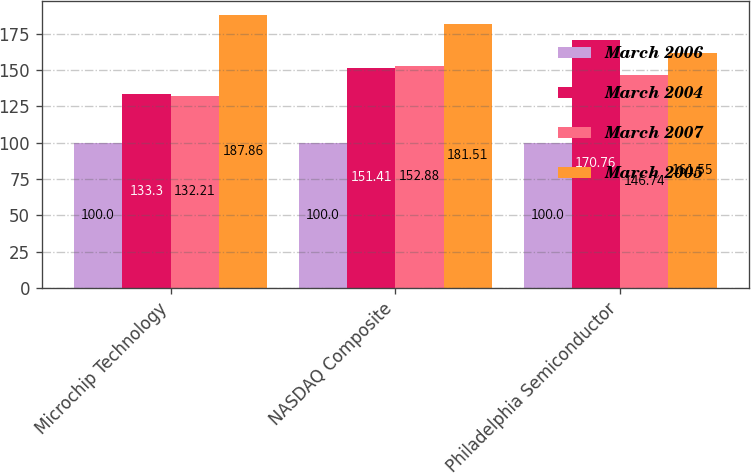<chart> <loc_0><loc_0><loc_500><loc_500><stacked_bar_chart><ecel><fcel>Microchip Technology<fcel>NASDAQ Composite<fcel>Philadelphia Semiconductor<nl><fcel>March 2006<fcel>100<fcel>100<fcel>100<nl><fcel>March 2004<fcel>133.3<fcel>151.41<fcel>170.76<nl><fcel>March 2007<fcel>132.21<fcel>152.88<fcel>146.74<nl><fcel>March 2005<fcel>187.86<fcel>181.51<fcel>161.55<nl></chart> 